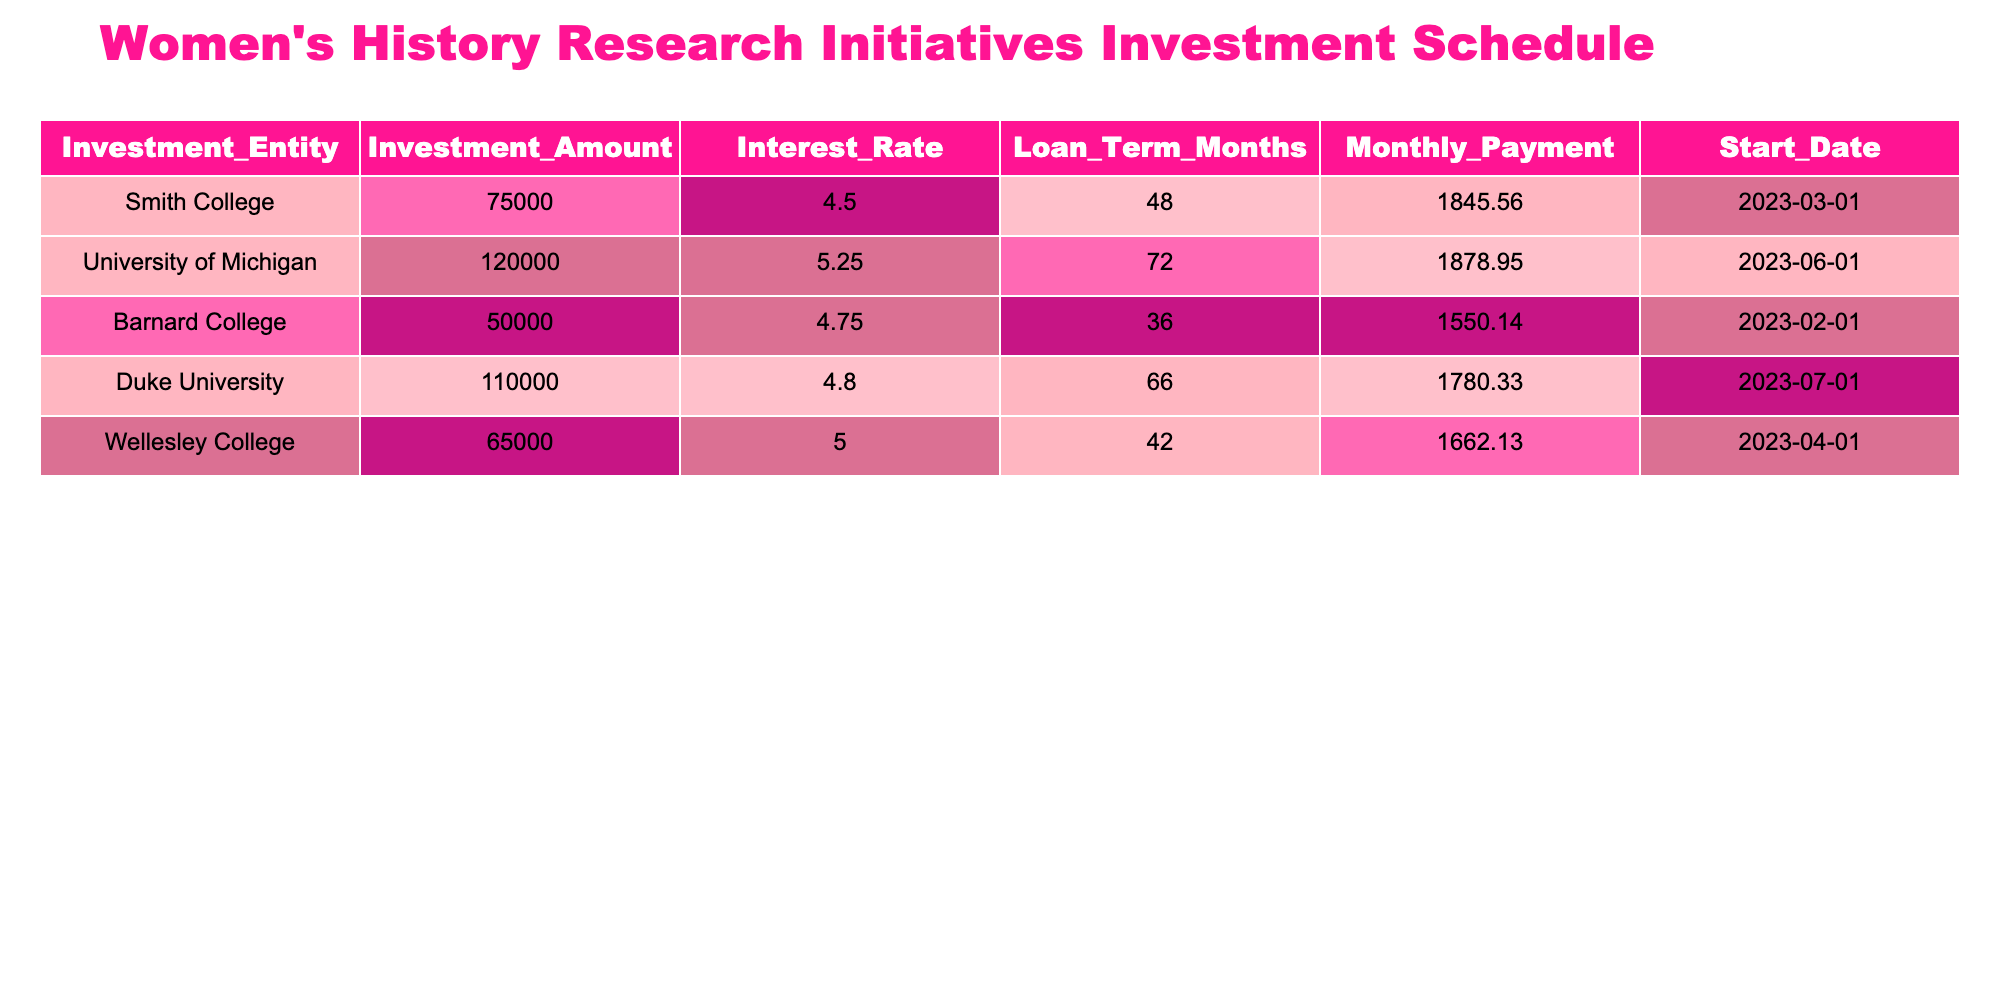What is the total investment amount for women's history research initiatives? To find the total investment amount, I will sum the 'Investment_Amount' column values: 75000 (Smith College) + 120000 (University of Michigan) + 50000 (Barnard College) + 110000 (Duke University) + 65000 (Wellesley College) = 400000.
Answer: 400000 Which institution has the highest interest rate on its investment? Looking through the 'Interest_Rate' column, I find that the University of Michigan has the highest interest rate of 5.25%.
Answer: University of Michigan How many months is the loan term for Duke University? The 'Loan_Term_Months' column lists Duke University's loan term as 66 months.
Answer: 66 Is the monthly payment for Barnard College greater than 1500? The monthly payment listed for Barnard College is 1550.14, which is greater than 1500. Therefore, the answer is yes.
Answer: Yes What is the average monthly payment across all institutions? To calculate the average monthly payment, I sum the monthly payments: 1845.56 (Smith College) + 1878.95 (University of Michigan) + 1550.14 (Barnard College) + 1780.33 (Duke University) + 1662.13 (Wellesley College) = 9707.11. Then I divide by the number of institutions, 5. Thus, 9707.11/5 = 1941.42 which is the average.
Answer: 1941.42 Which investment has the shortest loan term and what is the amount? Looking at the 'Loan_Term_Months' column, Barnard College has the shortest loan term at 36 months. The corresponding 'Investment_Amount' for Barnard College is 50000. So the answer includes both values.
Answer: Barnard College with 50000 What is the difference in monthly payment between the University of Michigan and Wellesley College? The monthly payment for the University of Michigan is 1878.95 and for Wellesley College, it is 1662.13. The difference is calculated by subtracting: 1878.95 - 1662.13 = 216.82.
Answer: 216.82 Does Smith College have the least investment amount among all the institutions? Looking at the 'Investment_Amount' column, Smith College has an investment amount of 75000, which is less compared to Barnard College's 50000 but more than several others. So the answer is no.
Answer: No What is the total investment amount for all institutions with an interest rate lower than 5%? The investments with interest rates lower than 5% are Barnard College (50000) and Wellesley College (65000). Adding these amounts gives 50000 + 65000 = 115000.
Answer: 115000 